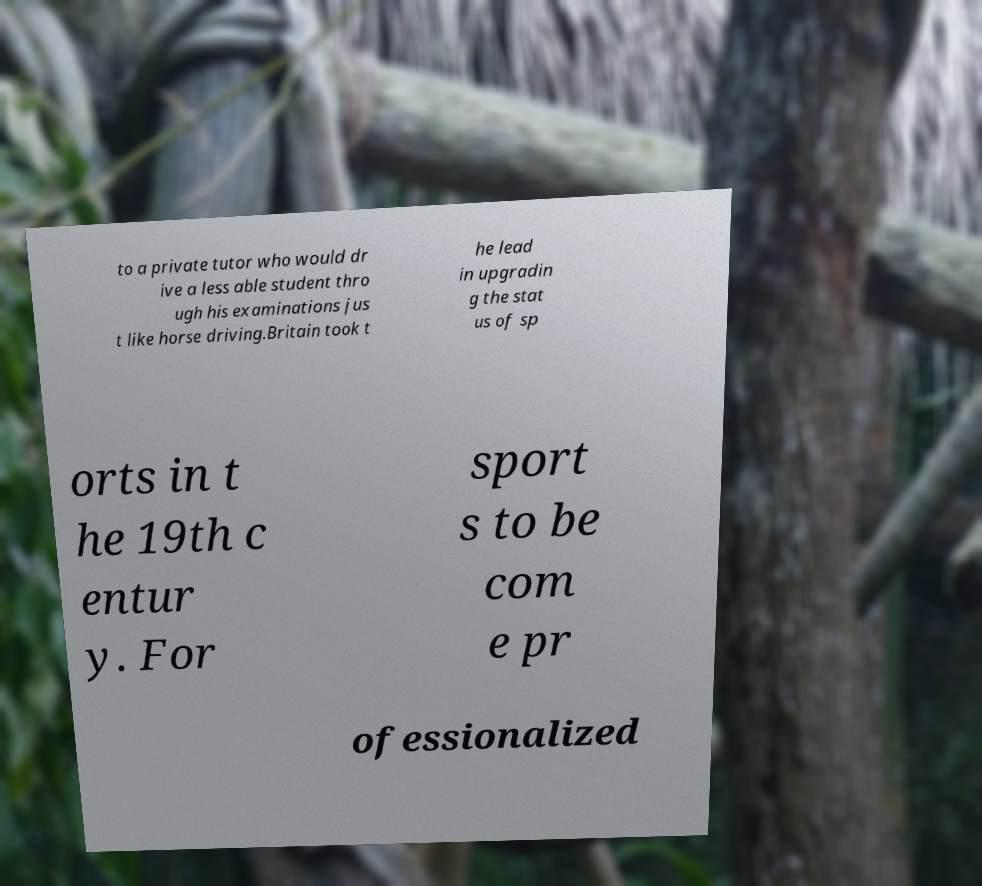There's text embedded in this image that I need extracted. Can you transcribe it verbatim? to a private tutor who would dr ive a less able student thro ugh his examinations jus t like horse driving.Britain took t he lead in upgradin g the stat us of sp orts in t he 19th c entur y. For sport s to be com e pr ofessionalized 